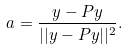Convert formula to latex. <formula><loc_0><loc_0><loc_500><loc_500>a = \frac { y - P y } { | | y - P y | | ^ { 2 } } .</formula> 